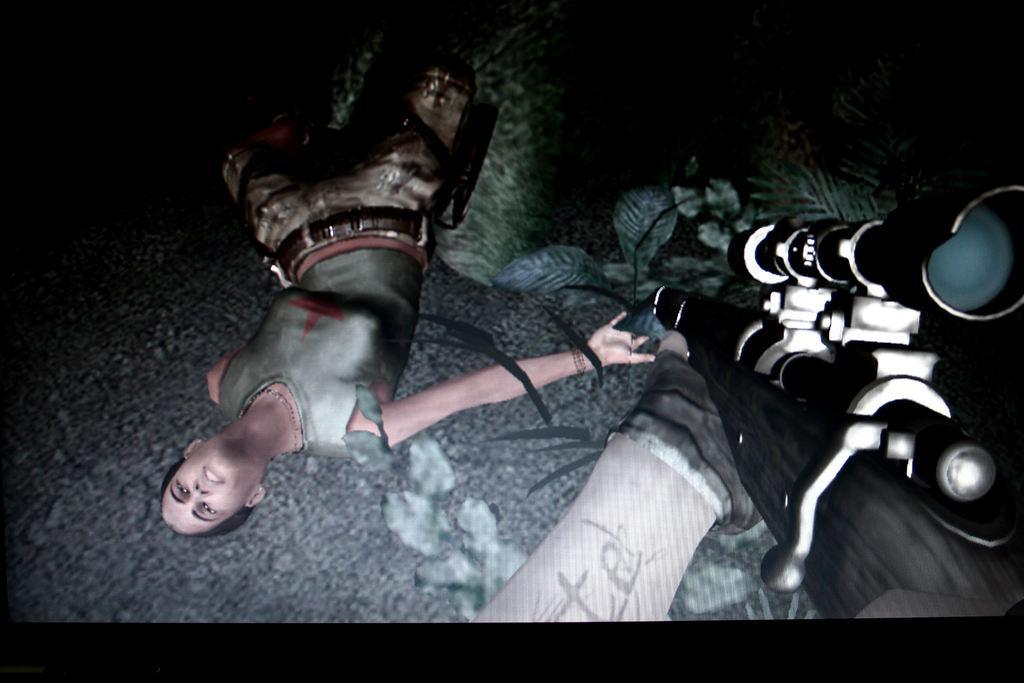Could you give a brief overview of what you see in this image? This is an animated image. In this image we can see a woman lying on the ground. We can also see some plants, grass and the hand of a person holding a gun. 